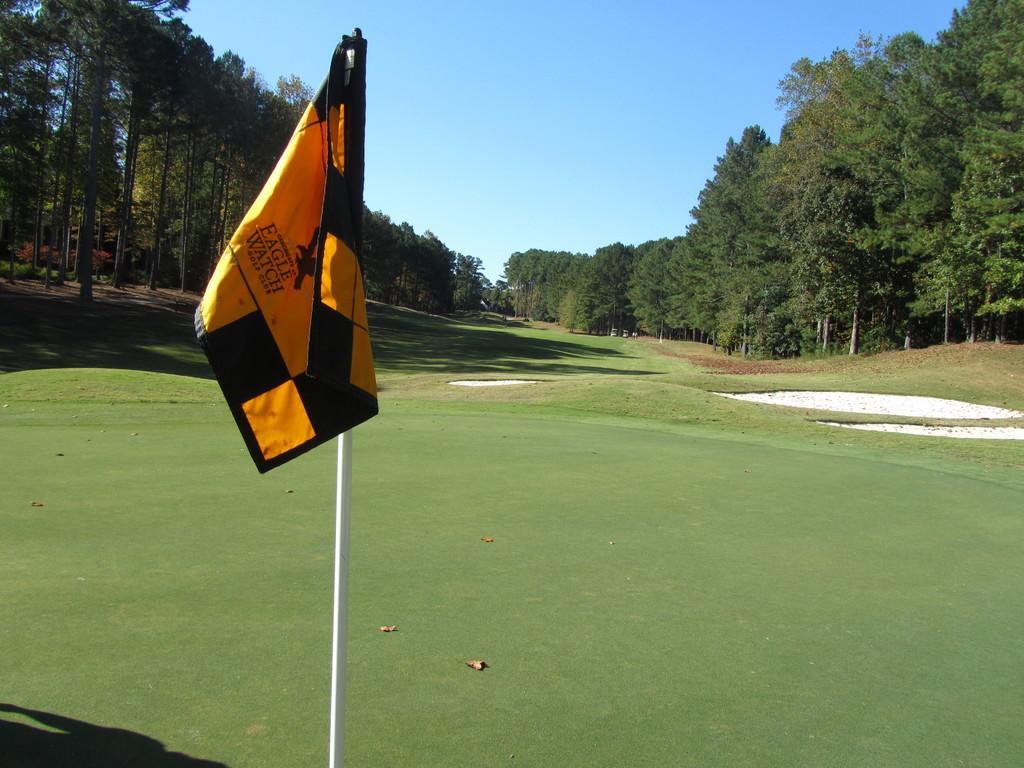Please provide a concise description of this image. In this image there is the sky truncated towards the top of the image, there are trees, there are trees truncated towards the right of the image, there are trees truncated towards the left of the image, there is the grass truncated towards the left of the image, there is the grass truncated towards the bottom of the image, there is the grass truncated towards the right of the image, there is a flag, there is a pole truncated towards the bottom of the image, there are dried leaves on the grass. 